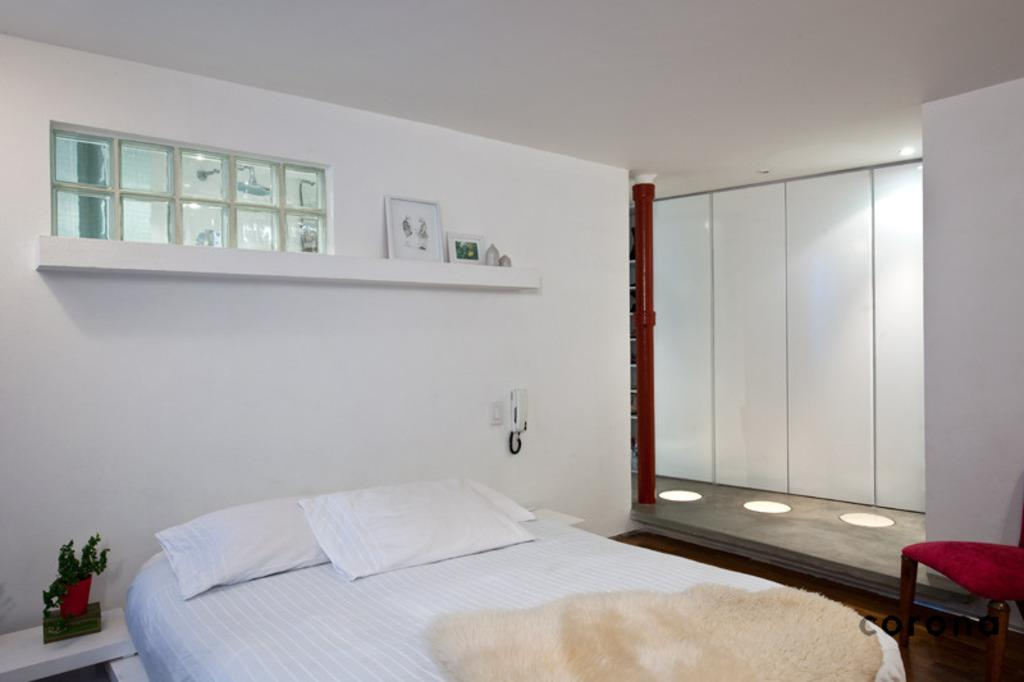What is on the bed in the image? There are pillows and cloth on the bed. What can be seen beside the bed? There is a plant beside the bed. What is on the table in the image? There is a box on the table. What type of furniture is in the image? There is a chair in the image. What is on the shelf in the image? There are frames and objects on the shelf. What is on the wall in the image? There are frames on the wall. What type of son can be seen playing with a jar in the image? There is no son or jar present in the image. What is the base of the plant in the image? The image does not provide information about the base of the plant. 